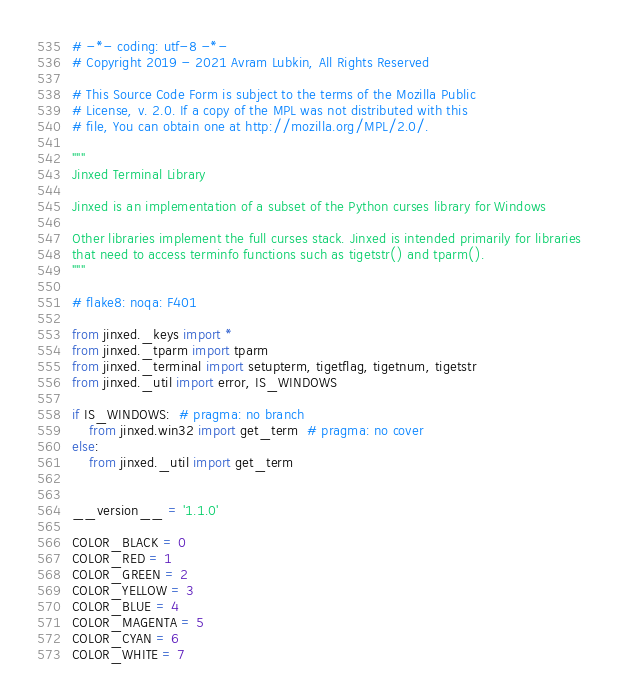Convert code to text. <code><loc_0><loc_0><loc_500><loc_500><_Python_># -*- coding: utf-8 -*-
# Copyright 2019 - 2021 Avram Lubkin, All Rights Reserved

# This Source Code Form is subject to the terms of the Mozilla Public
# License, v. 2.0. If a copy of the MPL was not distributed with this
# file, You can obtain one at http://mozilla.org/MPL/2.0/.

"""
Jinxed Terminal Library

Jinxed is an implementation of a subset of the Python curses library for Windows

Other libraries implement the full curses stack. Jinxed is intended primarily for libraries
that need to access terminfo functions such as tigetstr() and tparm().
"""

# flake8: noqa: F401

from jinxed._keys import *
from jinxed._tparm import tparm
from jinxed._terminal import setupterm, tigetflag, tigetnum, tigetstr
from jinxed._util import error, IS_WINDOWS

if IS_WINDOWS:  # pragma: no branch
    from jinxed.win32 import get_term  # pragma: no cover
else:
    from jinxed._util import get_term


__version__ = '1.1.0'

COLOR_BLACK = 0
COLOR_RED = 1
COLOR_GREEN = 2
COLOR_YELLOW = 3
COLOR_BLUE = 4
COLOR_MAGENTA = 5
COLOR_CYAN = 6
COLOR_WHITE = 7
</code> 